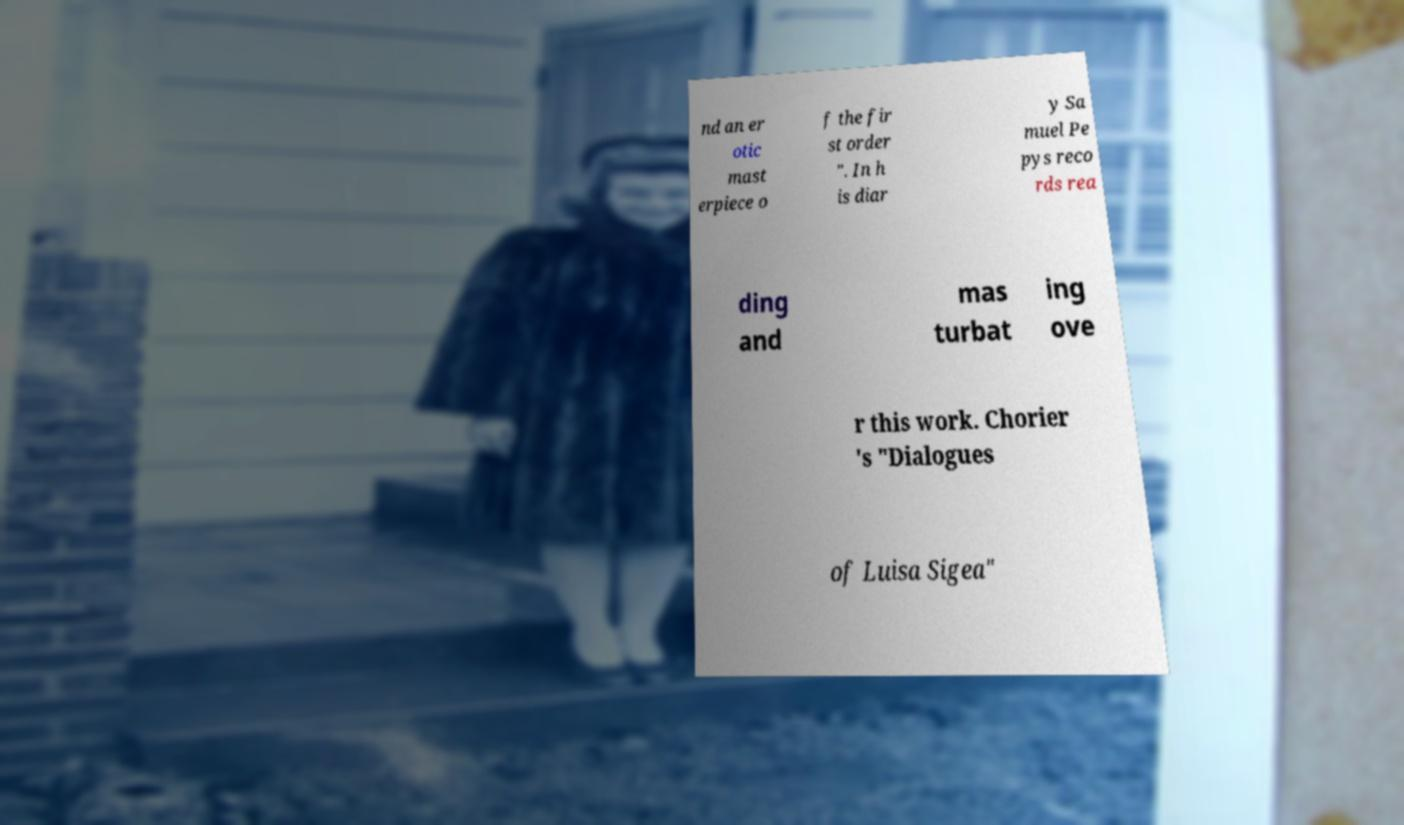Could you assist in decoding the text presented in this image and type it out clearly? nd an er otic mast erpiece o f the fir st order ". In h is diar y Sa muel Pe pys reco rds rea ding and mas turbat ing ove r this work. Chorier 's "Dialogues of Luisa Sigea" 